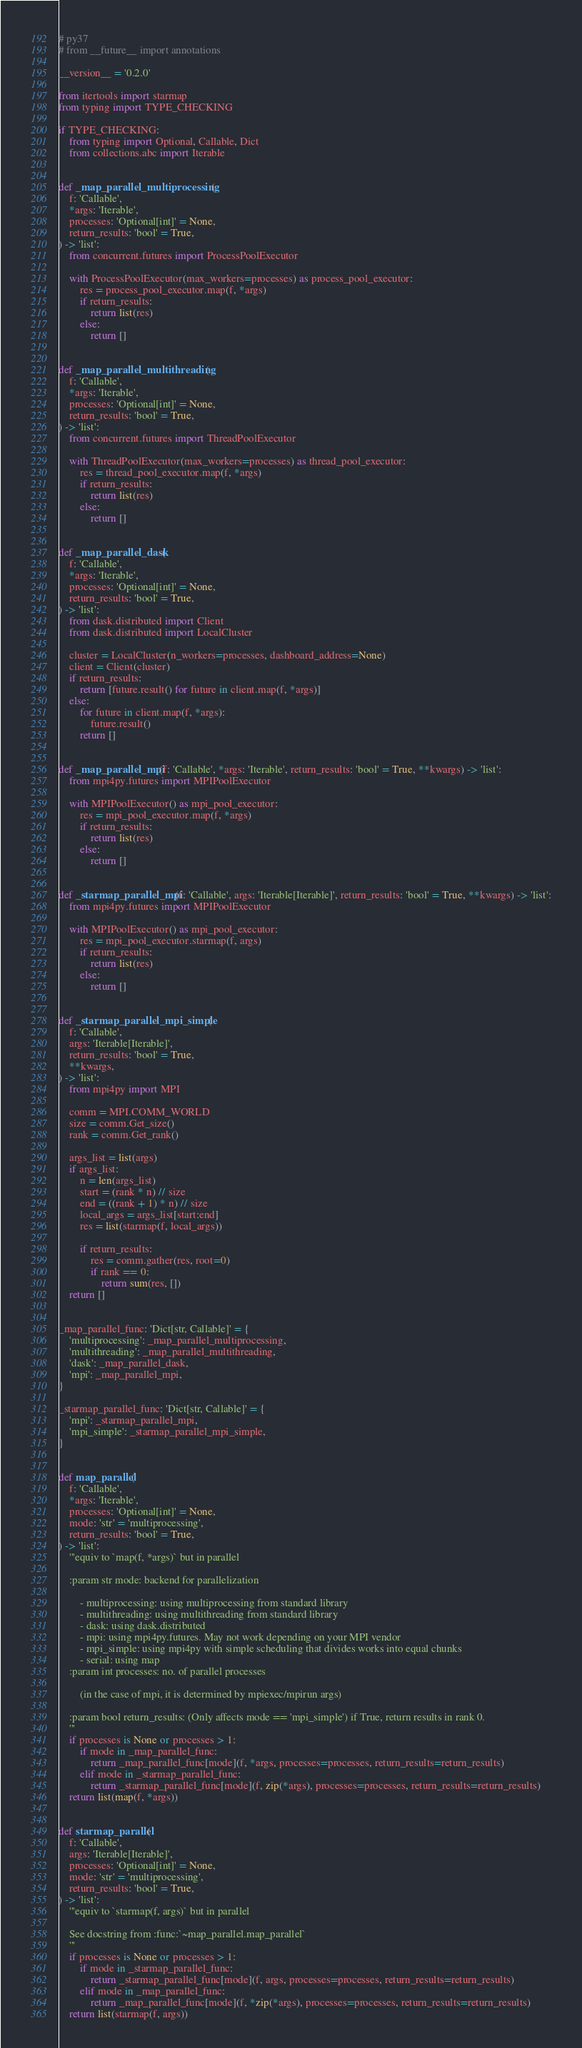<code> <loc_0><loc_0><loc_500><loc_500><_Python_># py37
# from __future__ import annotations

__version__ = '0.2.0'

from itertools import starmap
from typing import TYPE_CHECKING

if TYPE_CHECKING:
    from typing import Optional, Callable, Dict
    from collections.abc import Iterable


def _map_parallel_multiprocessing(
    f: 'Callable',
    *args: 'Iterable',
    processes: 'Optional[int]' = None,
    return_results: 'bool' = True,
) -> 'list':
    from concurrent.futures import ProcessPoolExecutor

    with ProcessPoolExecutor(max_workers=processes) as process_pool_executor:
        res = process_pool_executor.map(f, *args)
        if return_results:
            return list(res)
        else:
            return []


def _map_parallel_multithreading(
    f: 'Callable',
    *args: 'Iterable',
    processes: 'Optional[int]' = None,
    return_results: 'bool' = True,
) -> 'list':
    from concurrent.futures import ThreadPoolExecutor

    with ThreadPoolExecutor(max_workers=processes) as thread_pool_executor:
        res = thread_pool_executor.map(f, *args)
        if return_results:
            return list(res)
        else:
            return []


def _map_parallel_dask(
    f: 'Callable',
    *args: 'Iterable',
    processes: 'Optional[int]' = None,
    return_results: 'bool' = True,
) -> 'list':
    from dask.distributed import Client
    from dask.distributed import LocalCluster

    cluster = LocalCluster(n_workers=processes, dashboard_address=None)
    client = Client(cluster)
    if return_results:
        return [future.result() for future in client.map(f, *args)]
    else:
        for future in client.map(f, *args):
            future.result()
        return []


def _map_parallel_mpi(f: 'Callable', *args: 'Iterable', return_results: 'bool' = True, **kwargs) -> 'list':
    from mpi4py.futures import MPIPoolExecutor

    with MPIPoolExecutor() as mpi_pool_executor:
        res = mpi_pool_executor.map(f, *args)
        if return_results:
            return list(res)
        else:
            return []


def _starmap_parallel_mpi(f: 'Callable', args: 'Iterable[Iterable]', return_results: 'bool' = True, **kwargs) -> 'list':
    from mpi4py.futures import MPIPoolExecutor

    with MPIPoolExecutor() as mpi_pool_executor:
        res = mpi_pool_executor.starmap(f, args)
        if return_results:
            return list(res)
        else:
            return []


def _starmap_parallel_mpi_simple(
    f: 'Callable',
    args: 'Iterable[Iterable]',
    return_results: 'bool' = True,
    **kwargs,
) -> 'list':
    from mpi4py import MPI

    comm = MPI.COMM_WORLD
    size = comm.Get_size()
    rank = comm.Get_rank()

    args_list = list(args)
    if args_list:
        n = len(args_list)
        start = (rank * n) // size
        end = ((rank + 1) * n) // size
        local_args = args_list[start:end]
        res = list(starmap(f, local_args))

        if return_results:
            res = comm.gather(res, root=0)
            if rank == 0:
                return sum(res, [])
    return []


_map_parallel_func: 'Dict[str, Callable]' = {
    'multiprocessing': _map_parallel_multiprocessing,
    'multithreading': _map_parallel_multithreading,
    'dask': _map_parallel_dask,
    'mpi': _map_parallel_mpi,
}

_starmap_parallel_func: 'Dict[str, Callable]' = {
    'mpi': _starmap_parallel_mpi,
    'mpi_simple': _starmap_parallel_mpi_simple,
}


def map_parallel(
    f: 'Callable',
    *args: 'Iterable',
    processes: 'Optional[int]' = None,
    mode: 'str' = 'multiprocessing',
    return_results: 'bool' = True,
) -> 'list':
    '''equiv to `map(f, *args)` but in parallel

    :param str mode: backend for parallelization

        - multiprocessing: using multiprocessing from standard library
        - multithreading: using multithreading from standard library
        - dask: using dask.distributed
        - mpi: using mpi4py.futures. May not work depending on your MPI vendor
        - mpi_simple: using mpi4py with simple scheduling that divides works into equal chunks
        - serial: using map
    :param int processes: no. of parallel processes

        (in the case of mpi, it is determined by mpiexec/mpirun args)

    :param bool return_results: (Only affects mode == 'mpi_simple') if True, return results in rank 0.
    '''
    if processes is None or processes > 1:
        if mode in _map_parallel_func:
            return _map_parallel_func[mode](f, *args, processes=processes, return_results=return_results)
        elif mode in _starmap_parallel_func:
            return _starmap_parallel_func[mode](f, zip(*args), processes=processes, return_results=return_results)
    return list(map(f, *args))


def starmap_parallel(
    f: 'Callable',
    args: 'Iterable[Iterable]',
    processes: 'Optional[int]' = None,
    mode: 'str' = 'multiprocessing',
    return_results: 'bool' = True,
) -> 'list':
    '''equiv to `starmap(f, args)` but in parallel

    See docstring from :func:`~map_parallel.map_parallel`
    '''
    if processes is None or processes > 1:
        if mode in _starmap_parallel_func:
            return _starmap_parallel_func[mode](f, args, processes=processes, return_results=return_results)
        elif mode in _map_parallel_func:
            return _map_parallel_func[mode](f, *zip(*args), processes=processes, return_results=return_results)
    return list(starmap(f, args))
</code> 